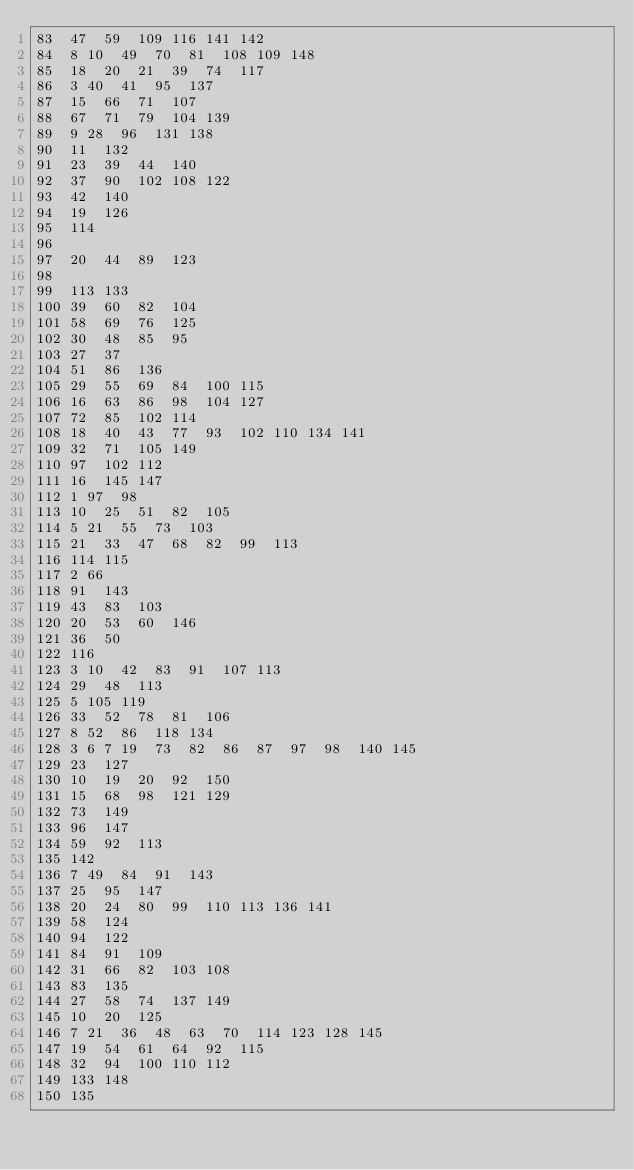<code> <loc_0><loc_0><loc_500><loc_500><_Perl_>83	47	59	109	116	141	142
84	8	10	49	70	81	108	109	148
85	18	20	21	39	74	117
86	3	40	41	95	137
87	15	66	71	107
88	67	71	79	104	139
89	9	28	96	131	138
90	11	132
91	23	39	44	140
92	37	90	102	108	122
93	42	140
94	19	126
95	114
96
97	20	44	89	123
98
99	113	133
100	39	60	82	104
101	58	69	76	125
102	30	48	85	95
103	27	37
104	51	86	136
105	29	55	69	84	100	115
106	16	63	86	98	104	127
107	72	85	102	114
108	18	40	43	77	93	102	110	134	141
109	32	71	105	149
110	97	102	112
111	16	145	147
112	1	97	98
113	10	25	51	82	105
114	5	21	55	73	103
115	21	33	47	68	82	99	113
116	114	115
117	2	66
118	91	143
119	43	83	103
120	20	53	60	146
121	36	50
122	116
123	3	10	42	83	91	107	113
124	29	48	113
125	5	105	119
126	33	52	78	81	106
127	8	52	86	118	134
128	3	6	7	19	73	82	86	87	97	98	140	145
129	23	127
130	10	19	20	92	150
131	15	68	98	121	129
132	73	149
133	96	147
134	59	92	113
135	142
136	7	49	84	91	143
137	25	95	147
138	20	24	80	99	110	113	136	141
139	58	124
140	94	122
141	84	91	109
142	31	66	82	103	108
143	83	135
144	27	58	74	137	149
145	10	20	125
146	7	21	36	48	63	70	114	123	128	145
147	19	54	61	64	92	115
148	32	94	100	110	112
149	133	148
150	135</code> 